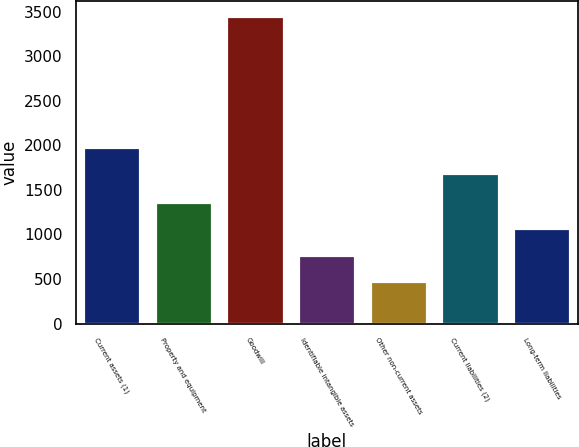Convert chart to OTSL. <chart><loc_0><loc_0><loc_500><loc_500><bar_chart><fcel>Current assets (1)<fcel>Property and equipment<fcel>Goodwill<fcel>Identifiable intangible assets<fcel>Other non-current assets<fcel>Current liabilities (2)<fcel>Long-term liabilities<nl><fcel>1986<fcel>1366<fcel>3452<fcel>770<fcel>472<fcel>1688<fcel>1068<nl></chart> 